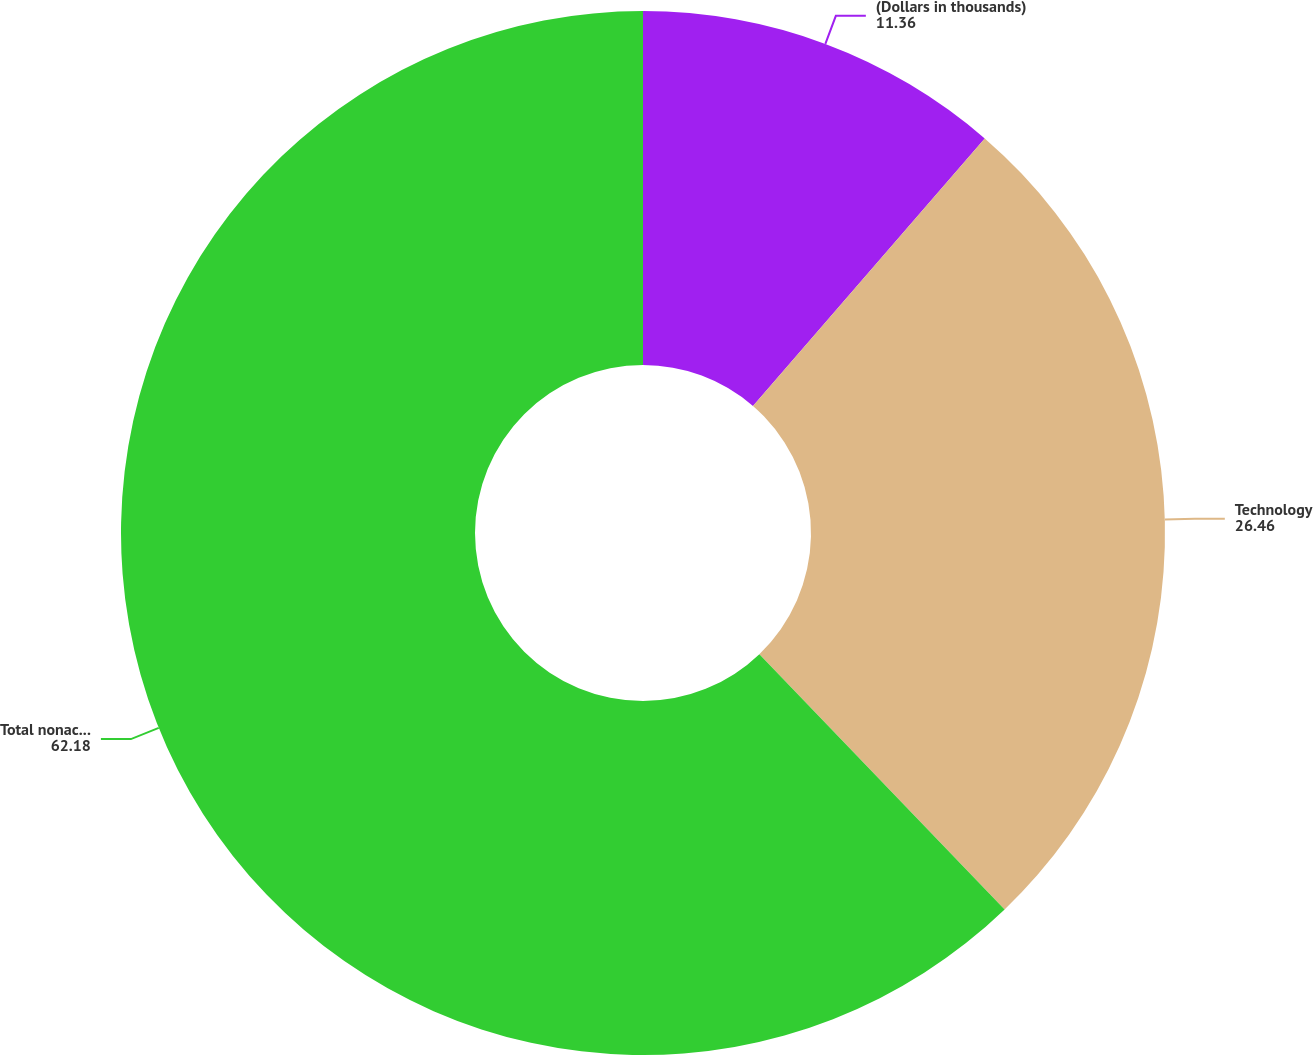Convert chart. <chart><loc_0><loc_0><loc_500><loc_500><pie_chart><fcel>(Dollars in thousands)<fcel>Technology<fcel>Total nonaccrual loans<nl><fcel>11.36%<fcel>26.46%<fcel>62.18%<nl></chart> 